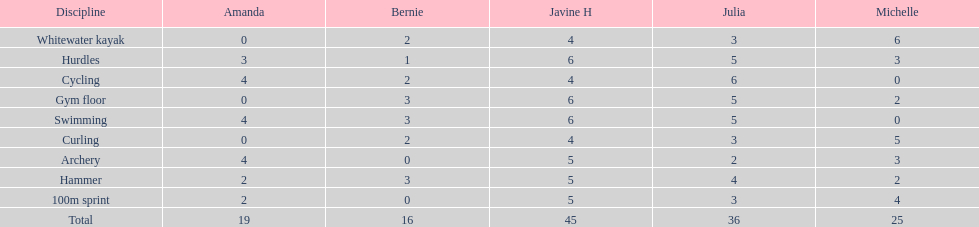Who scored the least on whitewater kayak? Amanda. 